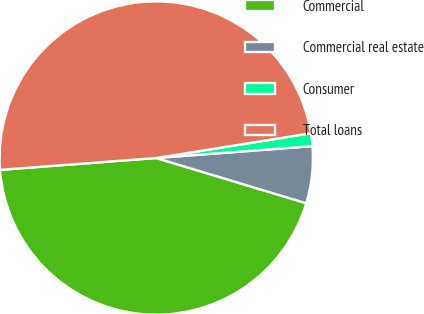<chart> <loc_0><loc_0><loc_500><loc_500><pie_chart><fcel>Commercial<fcel>Commercial real estate<fcel>Consumer<fcel>Total loans<nl><fcel>44.13%<fcel>5.87%<fcel>1.32%<fcel>48.68%<nl></chart> 